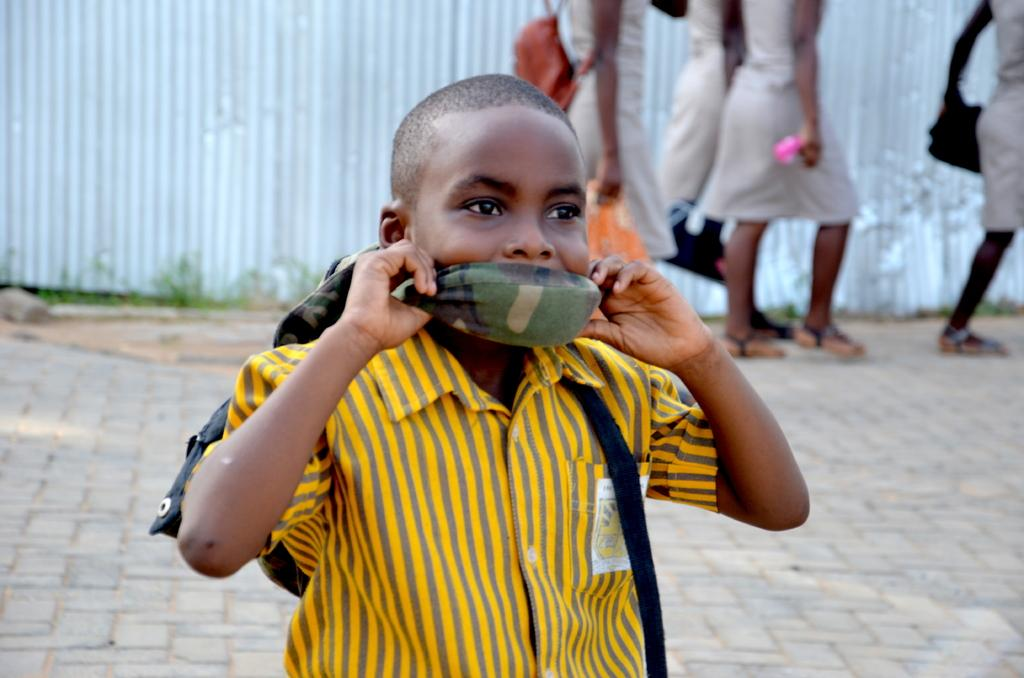What are the people in the image doing? The people in the image are walking. Can you describe the appearance of one of the individuals? There is a person wearing a bag in the image. Who else can be seen in the image? There is a boy in the image. What is the boy doing in the image? The boy has a cloth covering his mouth. What can be seen in the background of the image? There are metal sheets visible in the background of the image. What type of system is being used to prevent the worm from escaping in the image? There is no worm present in the image, and therefore no system to prevent its escape. 